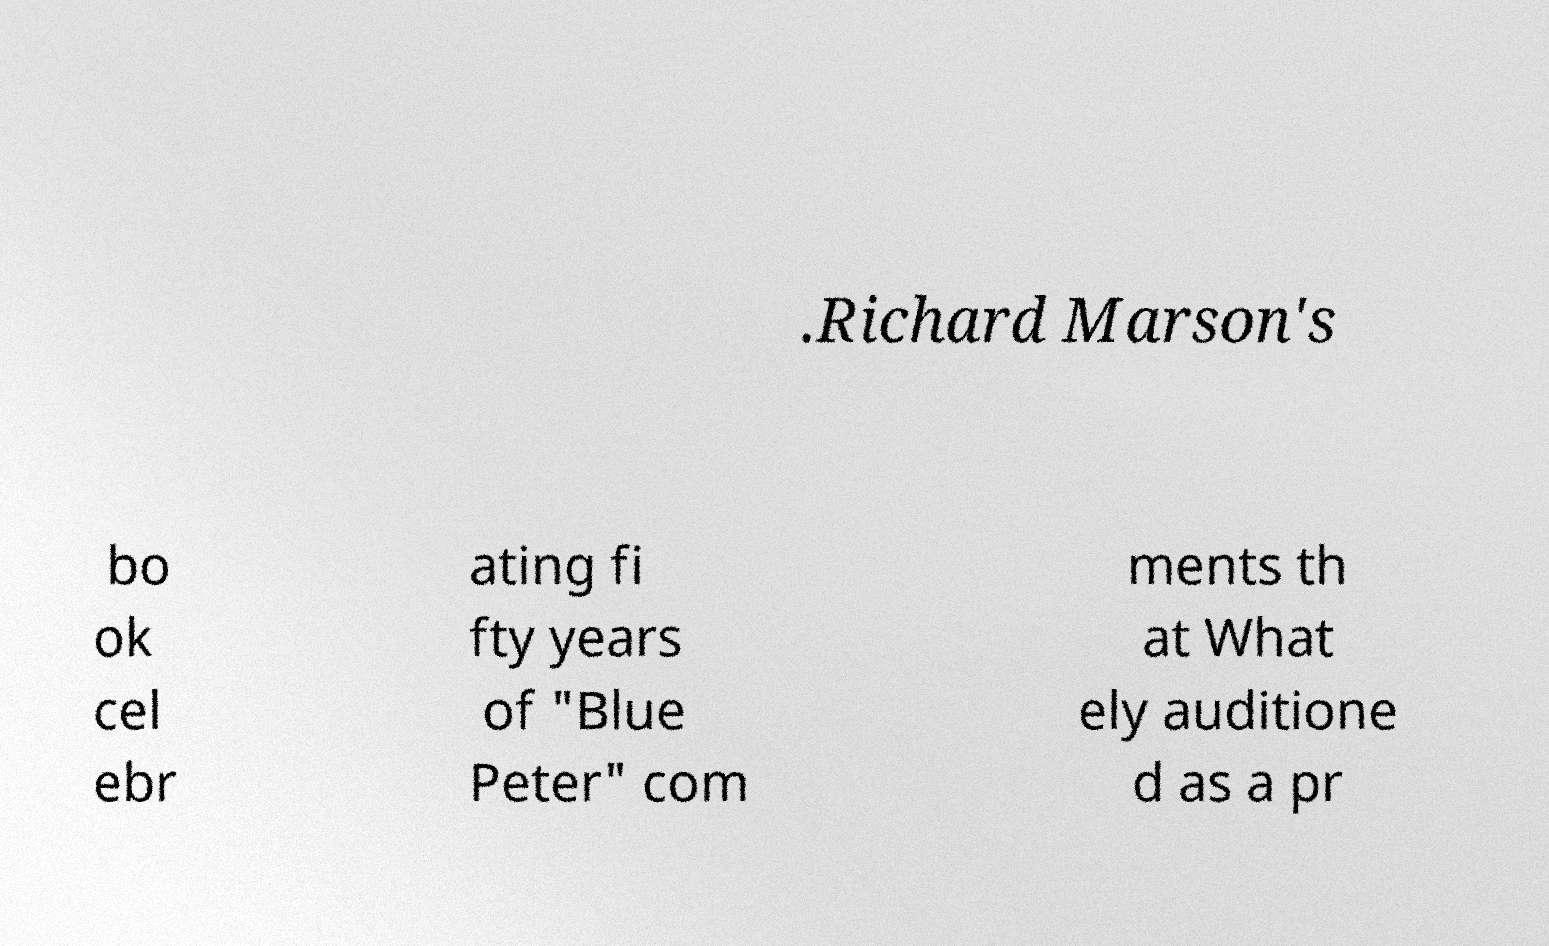Can you read and provide the text displayed in the image?This photo seems to have some interesting text. Can you extract and type it out for me? .Richard Marson's bo ok cel ebr ating fi fty years of "Blue Peter" com ments th at What ely auditione d as a pr 